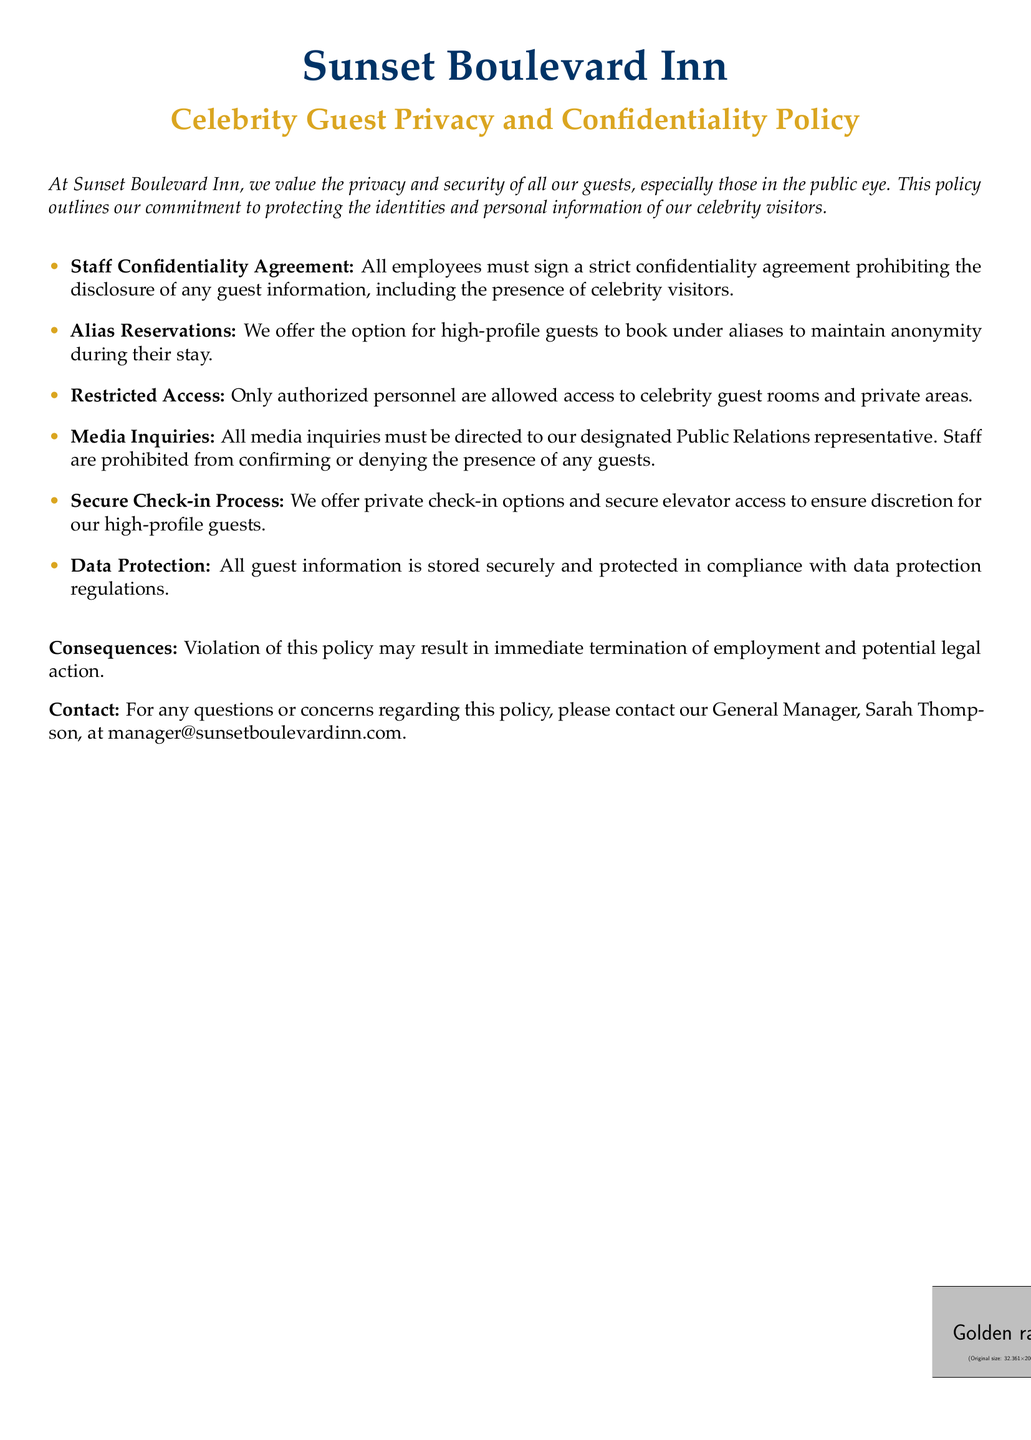What is the name of the hotel? The hotel name is mentioned at the beginning of the document.
Answer: Sunset Boulevard Inn Who is the General Manager to contact? The document specifies the contact person for any questions related to the policy.
Answer: Sarah Thompson What is the color used for the bullet points? The document specifies the color used for the bullet points in the itemized list.
Answer: Gold What must all employees sign? The document outlines a requirement that all staff must complete related to guest information.
Answer: Confidentiality agreement What should all media inquiries be directed to? The document outlines a specific representative for handling media inquiries.
Answer: Public Relations representative What is one method provided for celebrity guests to maintain anonymity? The policy states an option that high-profile guests can use to ensure their identity remains private.
Answer: Alias Reservations What consequence is mentioned for violating the policy? The document outlines a specific action that may result from policy violations.
Answer: Immediate termination What type of access is restricted? The policy specifies access control concerning certain areas of the hotel.
Answer: Celebrity guest rooms and private areas 